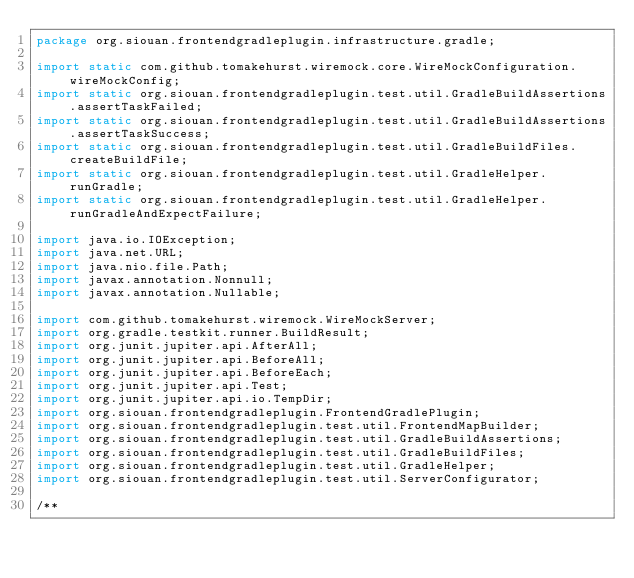Convert code to text. <code><loc_0><loc_0><loc_500><loc_500><_Java_>package org.siouan.frontendgradleplugin.infrastructure.gradle;

import static com.github.tomakehurst.wiremock.core.WireMockConfiguration.wireMockConfig;
import static org.siouan.frontendgradleplugin.test.util.GradleBuildAssertions.assertTaskFailed;
import static org.siouan.frontendgradleplugin.test.util.GradleBuildAssertions.assertTaskSuccess;
import static org.siouan.frontendgradleplugin.test.util.GradleBuildFiles.createBuildFile;
import static org.siouan.frontendgradleplugin.test.util.GradleHelper.runGradle;
import static org.siouan.frontendgradleplugin.test.util.GradleHelper.runGradleAndExpectFailure;

import java.io.IOException;
import java.net.URL;
import java.nio.file.Path;
import javax.annotation.Nonnull;
import javax.annotation.Nullable;

import com.github.tomakehurst.wiremock.WireMockServer;
import org.gradle.testkit.runner.BuildResult;
import org.junit.jupiter.api.AfterAll;
import org.junit.jupiter.api.BeforeAll;
import org.junit.jupiter.api.BeforeEach;
import org.junit.jupiter.api.Test;
import org.junit.jupiter.api.io.TempDir;
import org.siouan.frontendgradleplugin.FrontendGradlePlugin;
import org.siouan.frontendgradleplugin.test.util.FrontendMapBuilder;
import org.siouan.frontendgradleplugin.test.util.GradleBuildAssertions;
import org.siouan.frontendgradleplugin.test.util.GradleBuildFiles;
import org.siouan.frontendgradleplugin.test.util.GradleHelper;
import org.siouan.frontendgradleplugin.test.util.ServerConfigurator;

/**</code> 